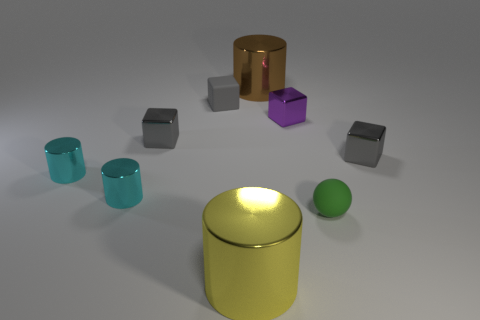Subtract all gray blocks. How many were subtracted if there are1gray blocks left? 2 Subtract all small gray rubber blocks. How many blocks are left? 3 Subtract all purple blocks. How many blocks are left? 3 Subtract all brown cylinders. How many gray cubes are left? 3 Add 1 small metal blocks. How many objects exist? 10 Subtract 3 cubes. How many cubes are left? 1 Subtract all cylinders. How many objects are left? 5 Subtract all brown blocks. Subtract all green cylinders. How many blocks are left? 4 Subtract all tiny brown rubber spheres. Subtract all tiny cylinders. How many objects are left? 7 Add 2 gray cubes. How many gray cubes are left? 5 